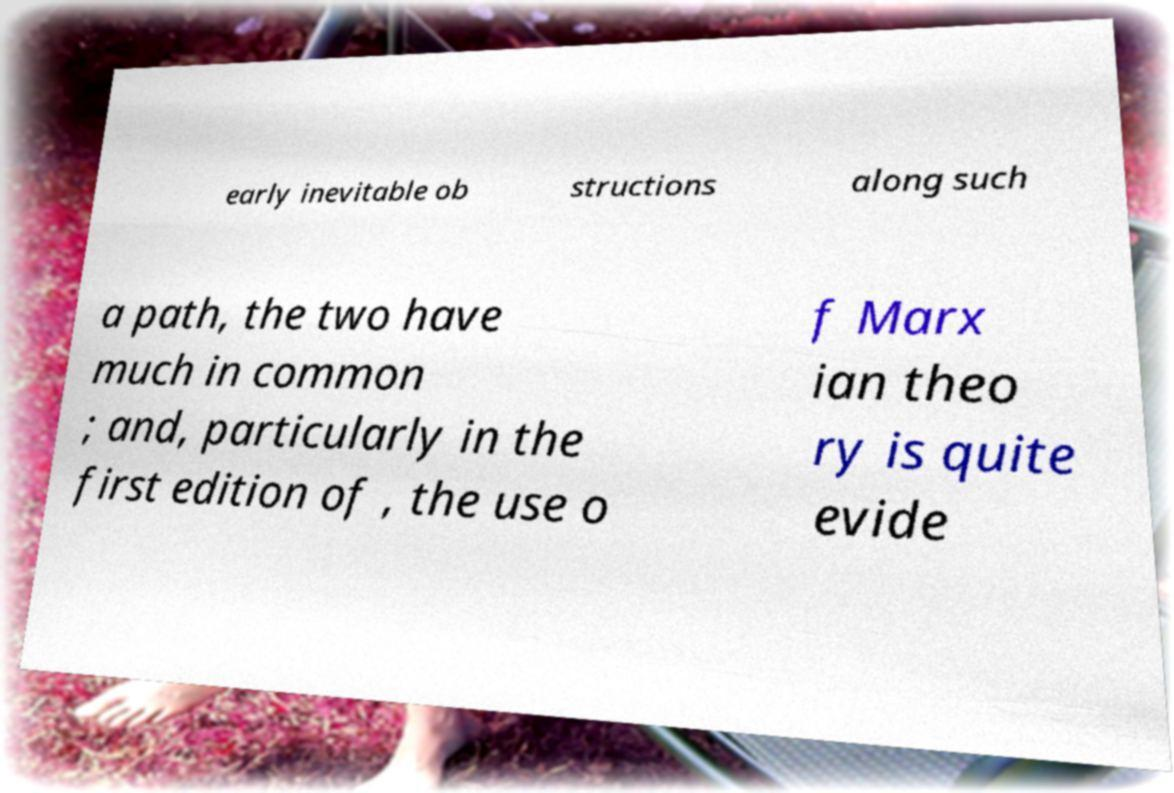Can you read and provide the text displayed in the image?This photo seems to have some interesting text. Can you extract and type it out for me? early inevitable ob structions along such a path, the two have much in common ; and, particularly in the first edition of , the use o f Marx ian theo ry is quite evide 